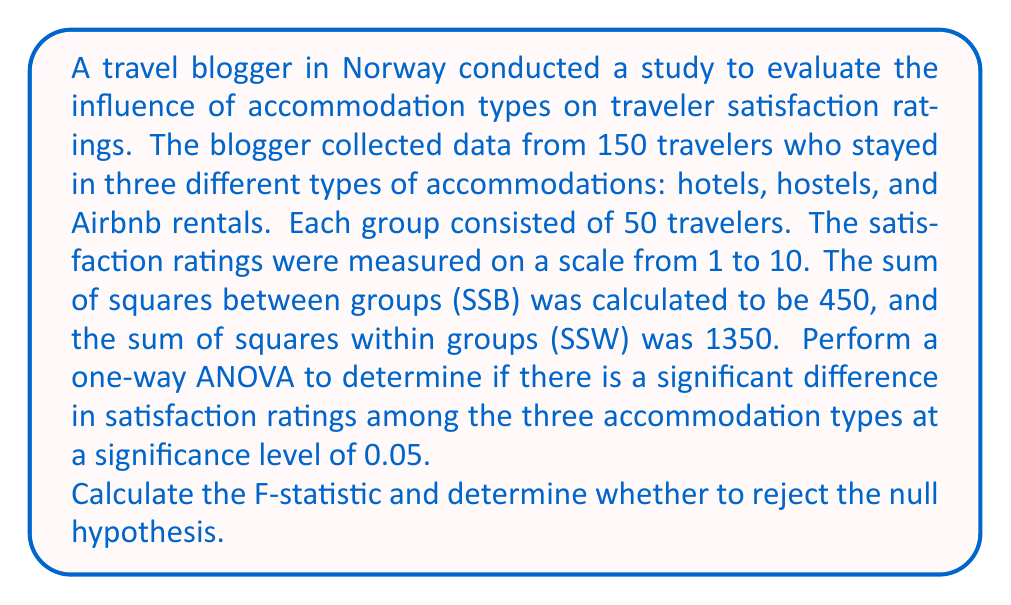Show me your answer to this math problem. To perform a one-way ANOVA, we need to follow these steps:

1. Calculate degrees of freedom:
   - Between groups: $df_B = k - 1 = 3 - 1 = 2$, where $k$ is the number of groups
   - Within groups: $df_W = N - k = 150 - 3 = 147$, where $N$ is the total sample size
   - Total: $df_T = N - 1 = 150 - 1 = 149$

2. Calculate Mean Square Between (MSB) and Mean Square Within (MSW):
   $$MSB = \frac{SSB}{df_B} = \frac{450}{2} = 225$$
   $$MSW = \frac{SSW}{df_W} = \frac{1350}{147} \approx 9.18$$

3. Calculate the F-statistic:
   $$F = \frac{MSB}{MSW} = \frac{225}{9.18} \approx 24.51$$

4. Determine the critical F-value:
   At $\alpha = 0.05$, with $df_B = 2$ and $df_W = 147$, the critical F-value is approximately 3.06 (from an F-distribution table or calculator).

5. Compare the F-statistic to the critical F-value:
   Since $24.51 > 3.06$, we reject the null hypothesis.

6. Conclusion:
   There is strong evidence to suggest that there is a significant difference in satisfaction ratings among the three accommodation types (hotels, hostels, and Airbnb rentals) at the 0.05 significance level.
Answer: The F-statistic is approximately 24.51. Since this value is greater than the critical F-value of 3.06, we reject the null hypothesis. There is a significant difference in satisfaction ratings among the three accommodation types. 